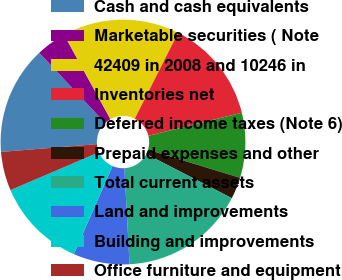Convert chart to OTSL. <chart><loc_0><loc_0><loc_500><loc_500><pie_chart><fcel>Cash and cash equivalents<fcel>Marketable securities ( Note<fcel>42409 in 2008 and 10246 in<fcel>Inventories net<fcel>Deferred income taxes (Note 6)<fcel>Prepaid expenses and other<fcel>Total current assets<fcel>Land and improvements<fcel>Building and improvements<fcel>Office furniture and equipment<nl><fcel>14.29%<fcel>4.0%<fcel>15.43%<fcel>13.71%<fcel>8.57%<fcel>2.86%<fcel>16.57%<fcel>7.43%<fcel>12.0%<fcel>5.14%<nl></chart> 